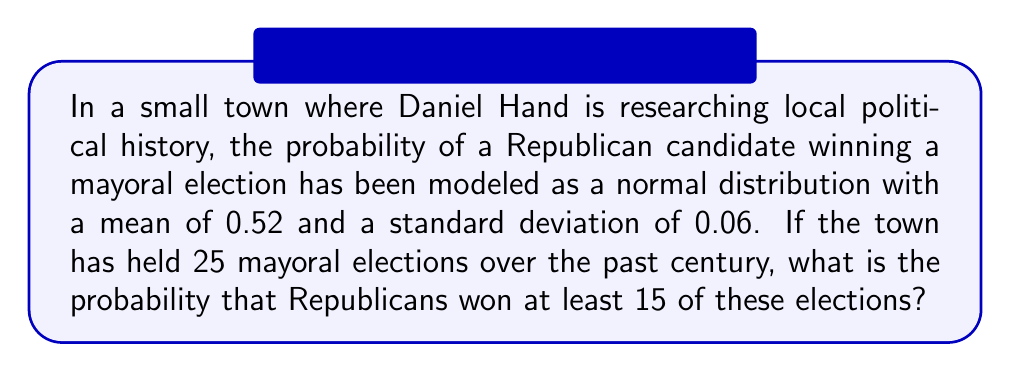Provide a solution to this math problem. Let's approach this step-by-step:

1) Let X be the number of Republican wins in 25 elections. X follows a binomial distribution with n = 25 and p = 0.52.

2) We need to find P(X ≥ 15).

3) For large n and p close to 0.5, we can approximate the binomial distribution with a normal distribution. Let's check if we can use this approximation:
   
   np = 25 * 0.52 = 13
   n(1-p) = 25 * 0.48 = 12
   
   Both are greater than 5, so we can use the normal approximation.

4) The mean of this normal approximation is:
   $$μ = np = 25 * 0.52 = 13$$

5) The standard deviation is:
   $$σ = \sqrt{np(1-p)} = \sqrt{25 * 0.52 * 0.48} = 2.5$$

6) We need to find P(X ≥ 15). With continuity correction, this becomes P(X > 14.5).

7) Standardizing, we get:
   $$z = \frac{14.5 - 13}{2.5} = 0.6$$

8) We need to find P(Z > 0.6), where Z is a standard normal variable.

9) From the standard normal table or calculator:
   P(Z > 0.6) = 1 - P(Z < 0.6) = 1 - 0.7257 = 0.2743

Therefore, the probability of Republicans winning at least 15 out of 25 elections is approximately 0.2743 or 27.43%.
Answer: 0.2743 